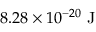<formula> <loc_0><loc_0><loc_500><loc_500>8 . 2 8 \times 1 0 ^ { - 2 0 } J</formula> 